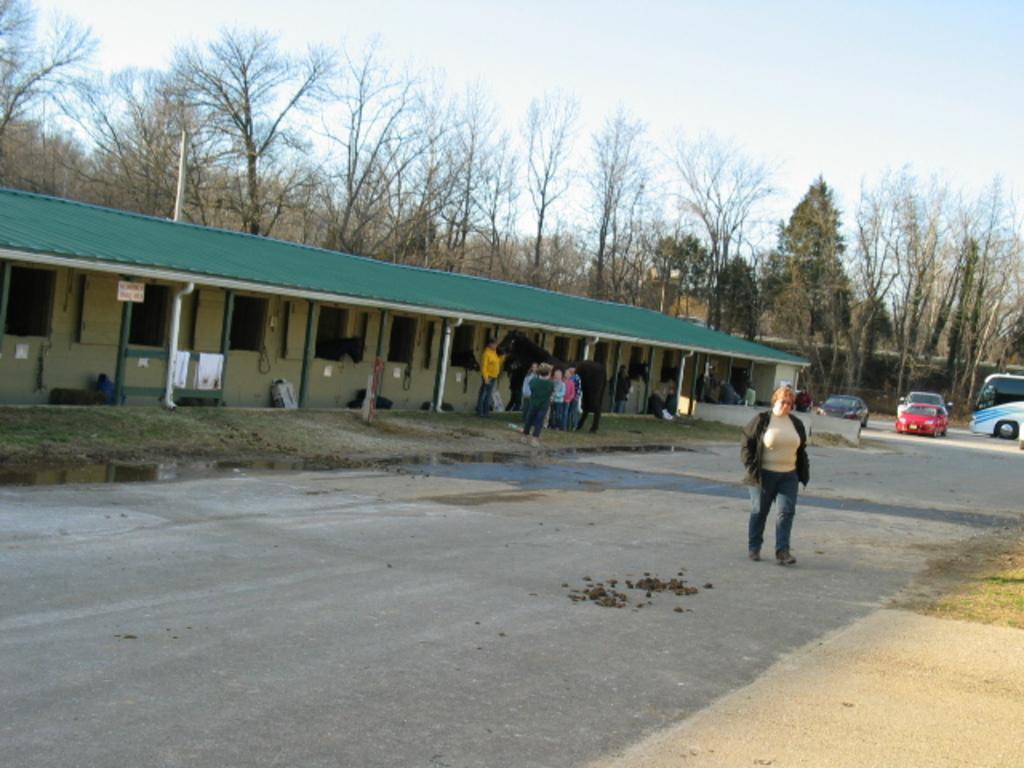In one or two sentences, can you explain what this image depicts? In this image we can see a woman is walking on the road. In the background we can see few persons, an animal, shed, objects,poles, vehicles on the road, trees and sky. 